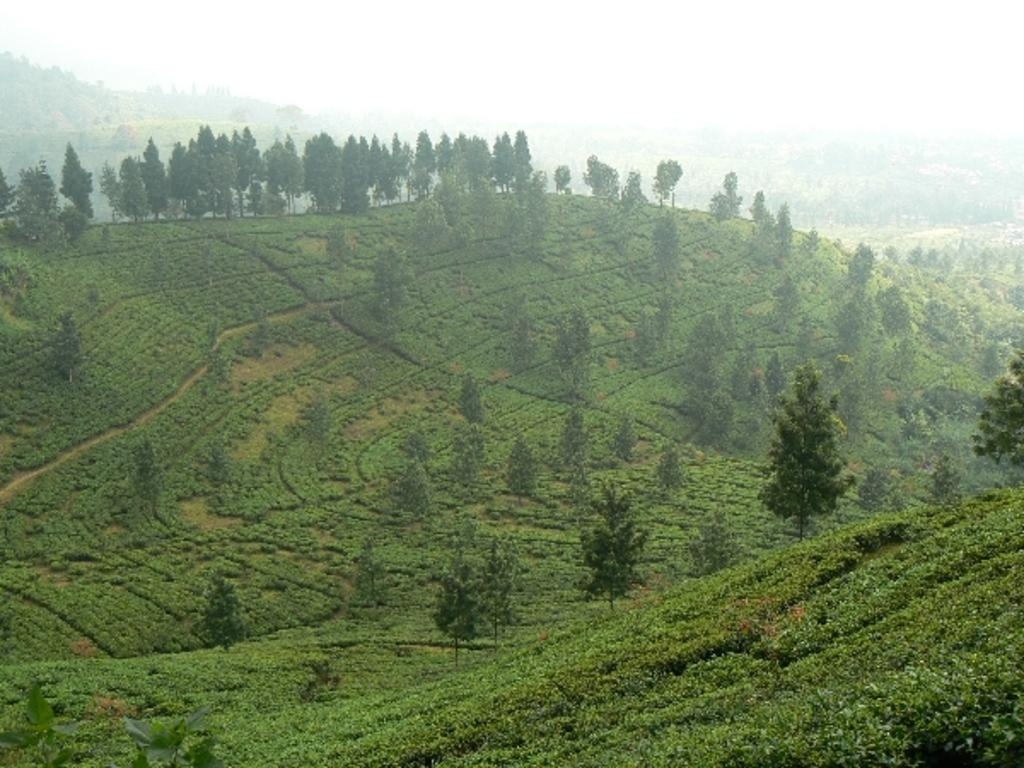What type of vegetation is at the bottom of the image? There is grass at the bottom of the image. What can be seen in the background of the image? There are groups of trees in the background of the image. How many hands are visible in the image? There are no hands visible in the image. What is the name of the son in the image? There is no son present in the image. 